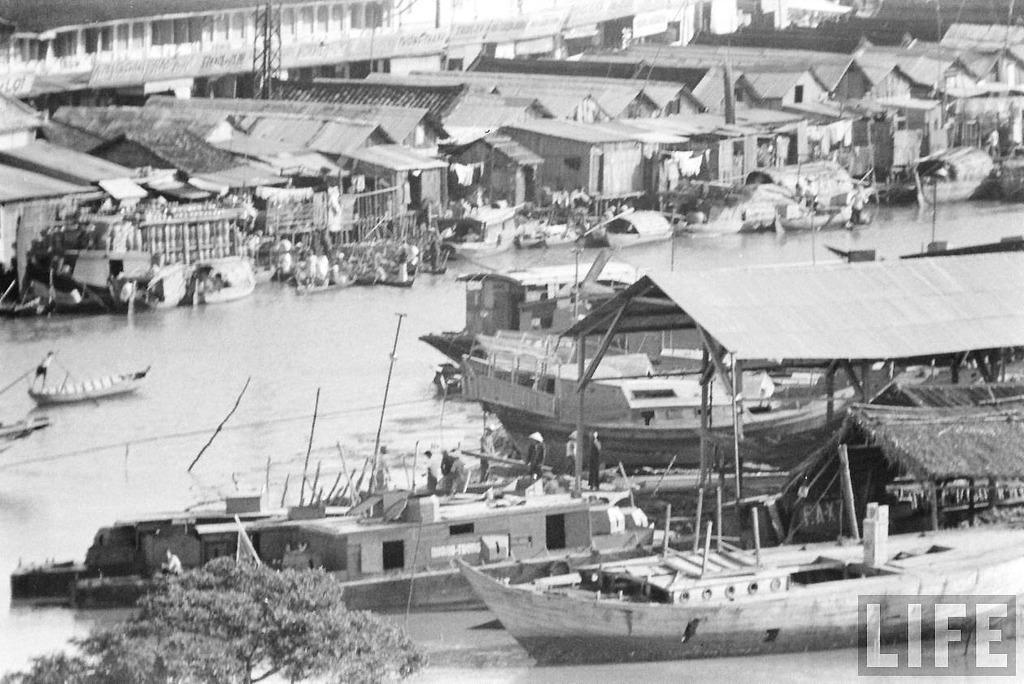What is present on the water in the image? There are boats on the water in the image. Can you identify any living beings in the image? Yes, there are people visible in the image. What type of structures can be seen in the image? There are houses and a tower in the image. What type of vegetation is present in the image? There are trees in the image. What is the color scheme of the image? The image is in black and white. What type of chain can be seen connecting the boats in the image? There is no chain connecting the boats in the image; they are simply floating on the water. What smell is present in the image? The image is a visual representation, so there is no smell associated with it. 